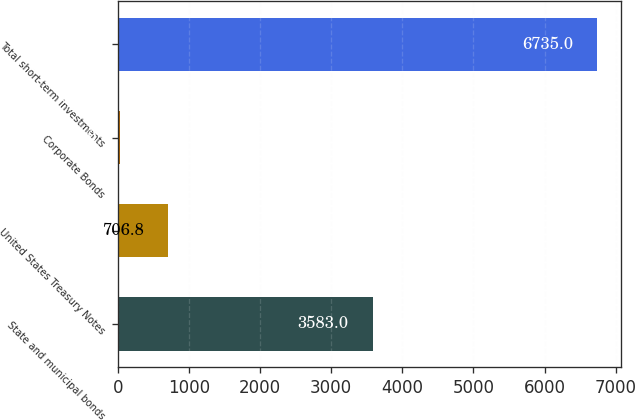<chart> <loc_0><loc_0><loc_500><loc_500><bar_chart><fcel>State and municipal bonds<fcel>United States Treasury Notes<fcel>Corporate Bonds<fcel>Total short-term investments<nl><fcel>3583<fcel>706.8<fcel>37<fcel>6735<nl></chart> 